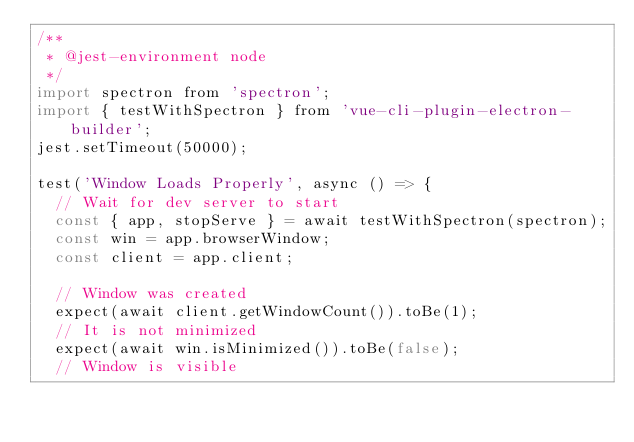Convert code to text. <code><loc_0><loc_0><loc_500><loc_500><_JavaScript_>/**
 * @jest-environment node
 */
import spectron from 'spectron';
import { testWithSpectron } from 'vue-cli-plugin-electron-builder';
jest.setTimeout(50000);

test('Window Loads Properly', async () => {
  // Wait for dev server to start
  const { app, stopServe } = await testWithSpectron(spectron);
  const win = app.browserWindow;
  const client = app.client;

  // Window was created
  expect(await client.getWindowCount()).toBe(1);
  // It is not minimized
  expect(await win.isMinimized()).toBe(false);
  // Window is visible</code> 